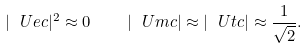Convert formula to latex. <formula><loc_0><loc_0><loc_500><loc_500>| \ U e c | ^ { 2 } \approx 0 \quad | \ U m c | \approx | \ U t c | \approx \frac { 1 } { \sqrt { 2 } } .</formula> 